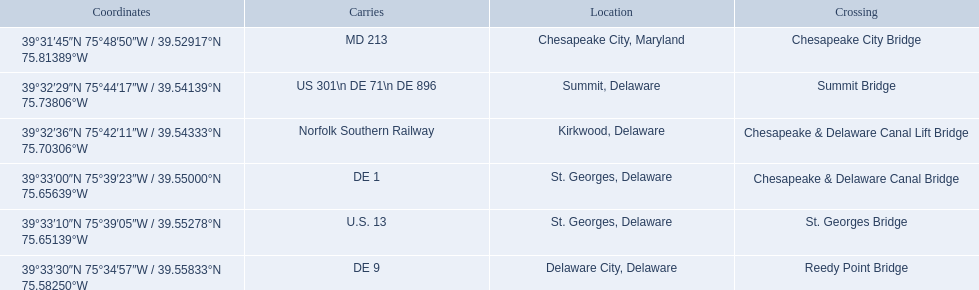What gets carried within the canal? MD 213, US 301\n DE 71\n DE 896, Norfolk Southern Railway, DE 1, U.S. 13, DE 9. Which of those carries de 9? DE 9. To what crossing does that entry correspond? Reedy Point Bridge. 